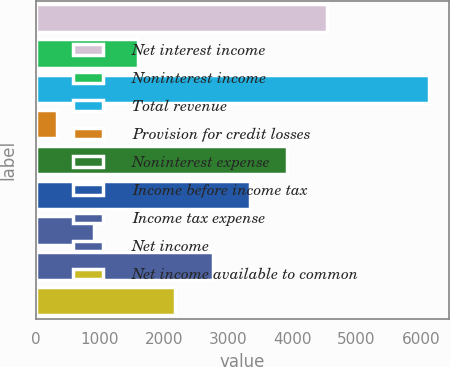<chart> <loc_0><loc_0><loc_500><loc_500><bar_chart><fcel>Net interest income<fcel>Noninterest income<fcel>Total revenue<fcel>Provision for credit losses<fcel>Noninterest expense<fcel>Income before income tax<fcel>Income tax expense<fcel>Net income<fcel>Net income available to common<nl><fcel>4532<fcel>1596<fcel>6128<fcel>326<fcel>3916.8<fcel>3336.6<fcel>906.2<fcel>2756.4<fcel>2176.2<nl></chart> 